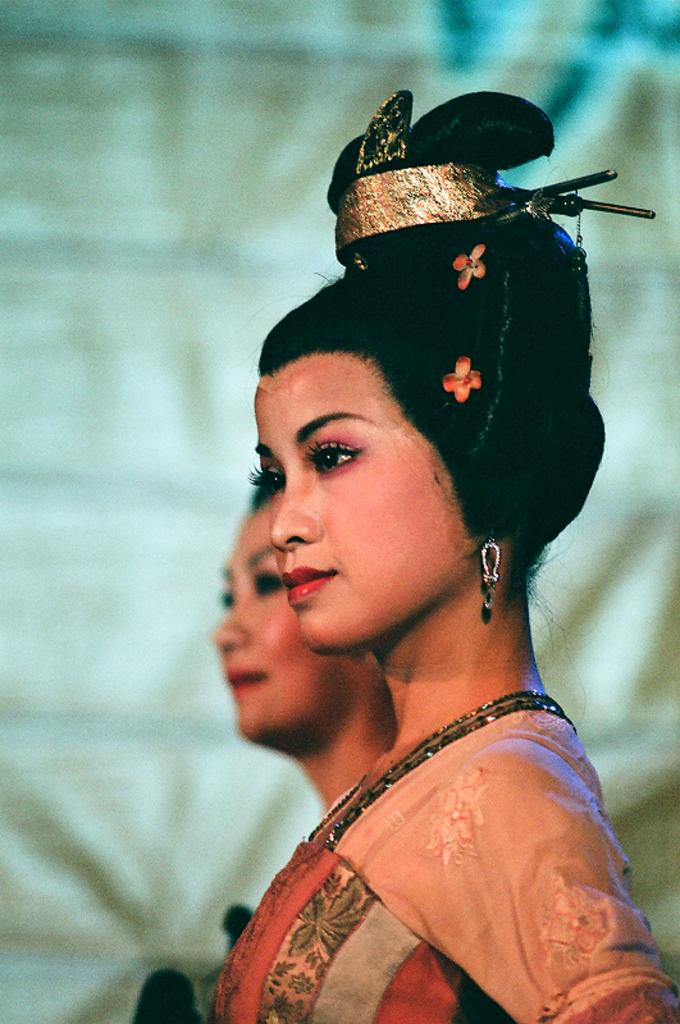How many people are in the image? There are two ladies in the image. Where are the ladies located in the image? The ladies are standing in the center of the image. What can be seen in the background of the image? There is a cloth visible in the background of the image. What type of organization is depicted in the image? There is no organization depicted in the image; it features two ladies standing in the center with a cloth visible in the background. 